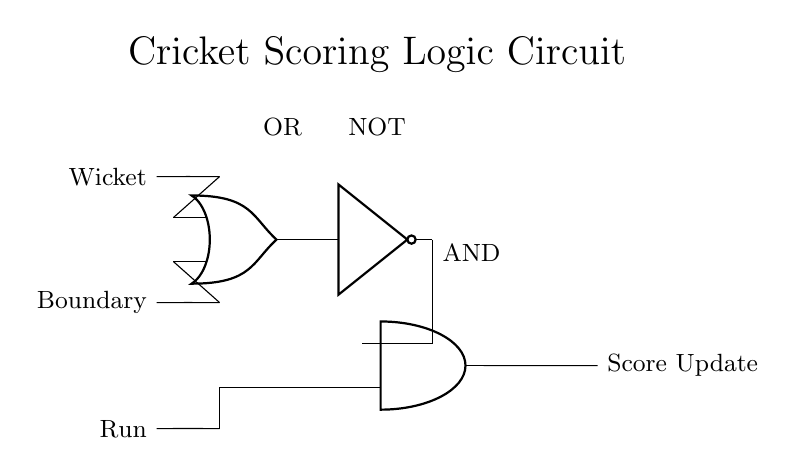What are the three input signals in the circuit? The input signals shown in the circuit are Wicket, Boundary, and Run, which are represented on the left side of the diagram.
Answer: Wicket, Boundary, Run What type of logic gate is used to process Wicket and Boundary signals? The circuit diagram shows an OR gate that takes Wicket and Boundary as inputs, which signifies that if either signal is present, it will output a high signal.
Answer: OR What is the purpose of the NOT gate in this circuit? The NOT gate inverts the output from the OR gate, so when there is at least one wicket or boundary, the NOT gate outputs a low signal that informs the next stage of the logic.
Answer: Inversion How many types of logic gates are used in the circuit? The circuit includes three types of logic gates: an OR gate, a NOT gate, and an AND gate, each performing a distinct logical function.
Answer: Three What is the output of the AND gate dependent on? The AND gate's output depends on the Run signal and the inverted output from the NOT gate, meaning both conditions must be satisfied for the AND gate to output a high signal indicating a score update.
Answer: Run and NOT output If there is a Run and no Wicket or Boundary, what is the output? In this case, since the OR gate does not receive any high signals, its output will be low, and after passing through the NOT gate, the output will be high, feeding into the AND gate which will be unable to produce a high output.
Answer: No output 